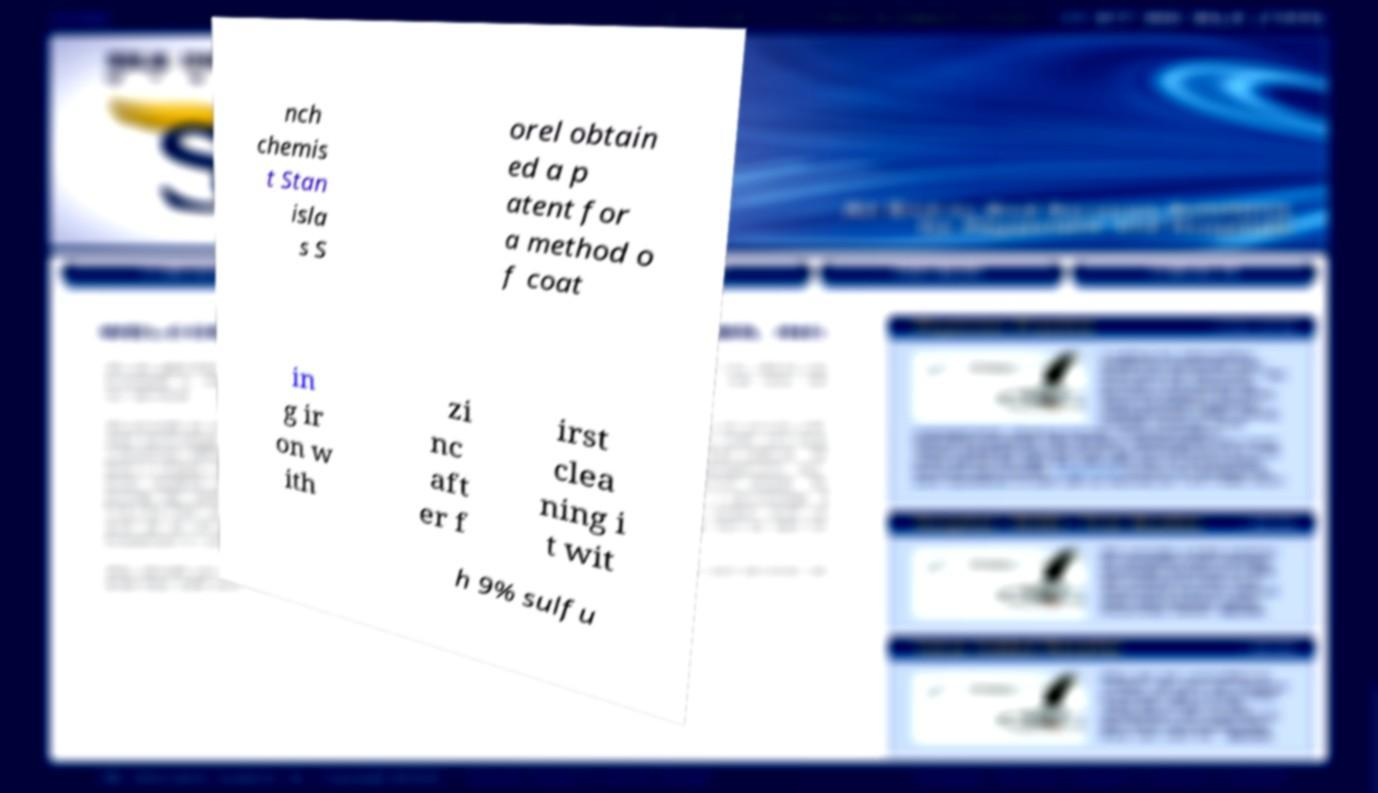Could you extract and type out the text from this image? nch chemis t Stan isla s S orel obtain ed a p atent for a method o f coat in g ir on w ith zi nc aft er f irst clea ning i t wit h 9% sulfu 